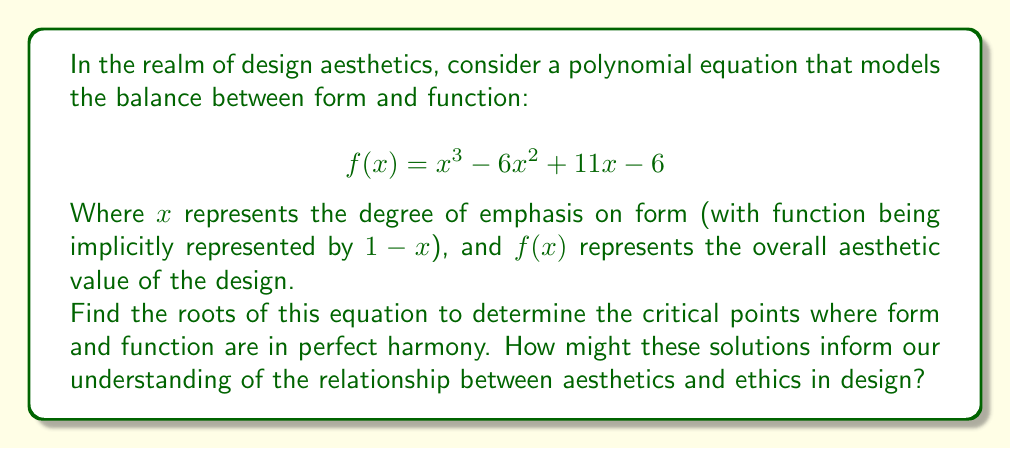Can you answer this question? To find the roots of the polynomial equation, we need to factor it. Let's approach this step-by-step:

1) First, let's check if there are any rational roots using the rational root theorem. The possible rational roots are the factors of the constant term: ±1, ±2, ±3, ±6.

2) Testing these values, we find that $f(1) = 0$. So $x = 1$ is a root.

3) We can factor out $(x-1)$:

   $$f(x) = (x-1)(x^2 - 5x + 6)$$

4) Now we need to factor the quadratic term $x^2 - 5x + 6$. We can do this by finding two numbers that multiply to give 6 and add to give -5. These numbers are -2 and -3.

5) So our final factorization is:

   $$f(x) = (x-1)(x-2)(x-3)$$

6) The roots of the equation are therefore $x = 1$, $x = 2$, and $x = 3$.

Interpreting these results in the context of design and aesthetics:

- $x = 1$ suggests a perfect balance where form and function are equally emphasized.
- $x = 2$ and $x = 3$ indicate points where a greater emphasis on form still results in aesthetic harmony.

These solutions suggest that there's not just one "perfect" balance between form and function, but rather multiple points of harmony. This could inform our understanding of aesthetics and ethics in design by suggesting that ethical design doesn't necessarily mean sacrificing form for function, but rather finding multiple ways to balance these elements effectively.
Answer: The roots of the equation are $x = 1$, $x = 2$, and $x = 3$. 